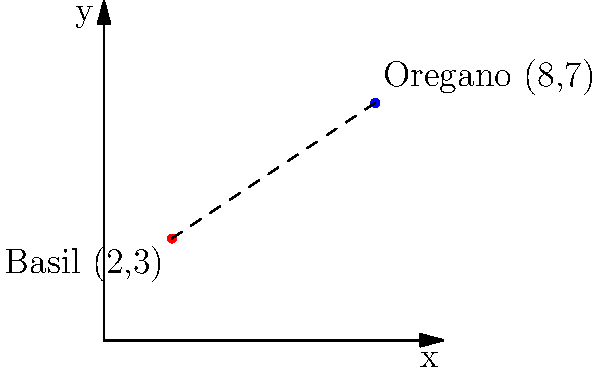At Piccolo Italian Market & Deli, you're discussing Mediterranean herb gardens with the owner. He shows you a graph representing the locations of different herb plots. Basil is planted at coordinates (2,3) and oregano at (8,7). What is the straight-line distance between these two herb plots, rounded to the nearest tenth of a unit? To find the distance between two points on a coordinate plane, we use the distance formula:

$$ d = \sqrt{(x_2 - x_1)^2 + (y_2 - y_1)^2} $$

Where $(x_1, y_1)$ is the first point and $(x_2, y_2)$ is the second point.

Step 1: Identify the coordinates
- Basil: $(x_1, y_1) = (2, 3)$
- Oregano: $(x_2, y_2) = (8, 7)$

Step 2: Plug the values into the distance formula
$$ d = \sqrt{(8 - 2)^2 + (7 - 3)^2} $$

Step 3: Simplify inside the parentheses
$$ d = \sqrt{6^2 + 4^2} $$

Step 4: Calculate the squares
$$ d = \sqrt{36 + 16} $$

Step 5: Add under the square root
$$ d = \sqrt{52} $$

Step 6: Simplify the square root
$$ d \approx 7.21110255 $$

Step 7: Round to the nearest tenth
$$ d \approx 7.2 $$

Therefore, the distance between the basil and oregano plots is approximately 7.2 units.
Answer: 7.2 units 